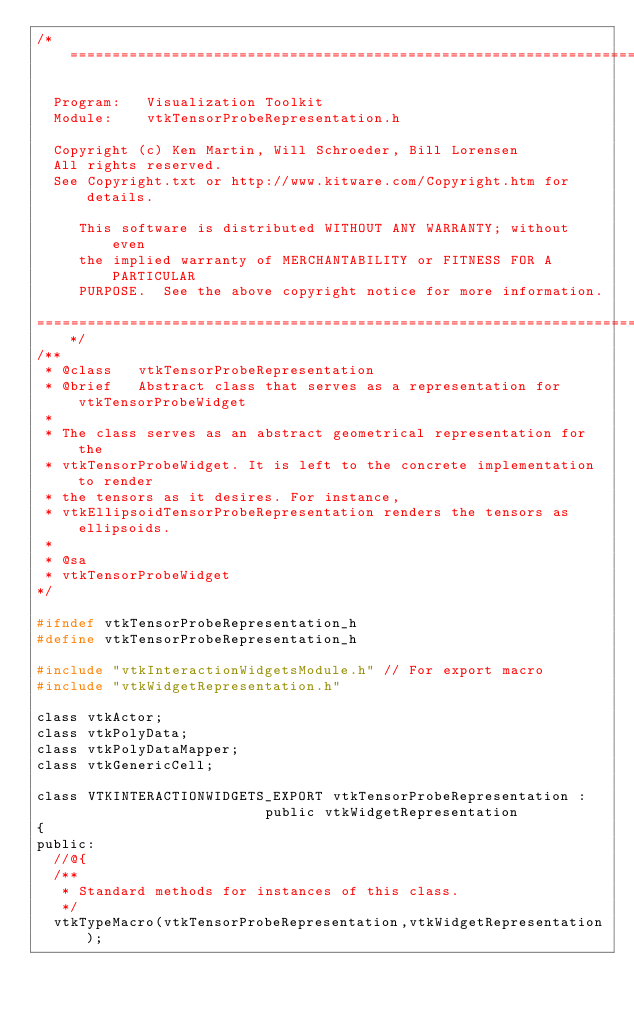Convert code to text. <code><loc_0><loc_0><loc_500><loc_500><_C_>/*=========================================================================

  Program:   Visualization Toolkit
  Module:    vtkTensorProbeRepresentation.h

  Copyright (c) Ken Martin, Will Schroeder, Bill Lorensen
  All rights reserved.
  See Copyright.txt or http://www.kitware.com/Copyright.htm for details.

     This software is distributed WITHOUT ANY WARRANTY; without even
     the implied warranty of MERCHANTABILITY or FITNESS FOR A PARTICULAR
     PURPOSE.  See the above copyright notice for more information.

=========================================================================*/
/**
 * @class   vtkTensorProbeRepresentation
 * @brief   Abstract class that serves as a representation for vtkTensorProbeWidget
 *
 * The class serves as an abstract geometrical representation for the
 * vtkTensorProbeWidget. It is left to the concrete implementation to render
 * the tensors as it desires. For instance,
 * vtkEllipsoidTensorProbeRepresentation renders the tensors as ellipsoids.
 *
 * @sa
 * vtkTensorProbeWidget
*/

#ifndef vtkTensorProbeRepresentation_h
#define vtkTensorProbeRepresentation_h

#include "vtkInteractionWidgetsModule.h" // For export macro
#include "vtkWidgetRepresentation.h"

class vtkActor;
class vtkPolyData;
class vtkPolyDataMapper;
class vtkGenericCell;

class VTKINTERACTIONWIDGETS_EXPORT vtkTensorProbeRepresentation :
                           public vtkWidgetRepresentation
{
public:
  //@{
  /**
   * Standard methods for instances of this class.
   */
  vtkTypeMacro(vtkTensorProbeRepresentation,vtkWidgetRepresentation);</code> 